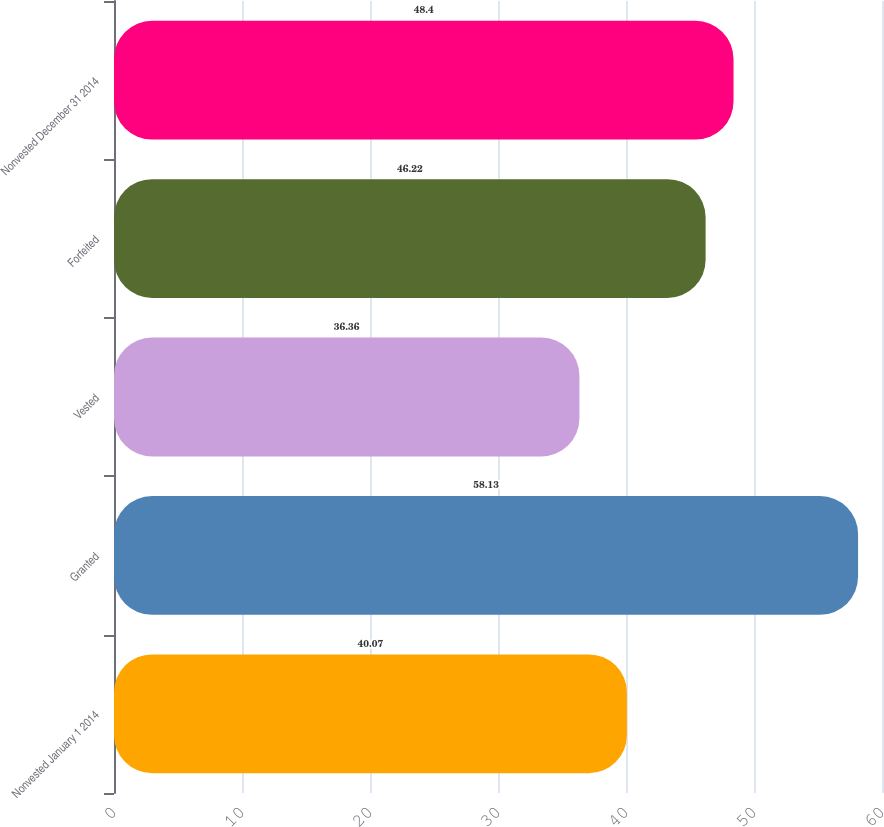<chart> <loc_0><loc_0><loc_500><loc_500><bar_chart><fcel>Nonvested January 1 2014<fcel>Granted<fcel>Vested<fcel>Forfeited<fcel>Nonvested December 31 2014<nl><fcel>40.07<fcel>58.13<fcel>36.36<fcel>46.22<fcel>48.4<nl></chart> 